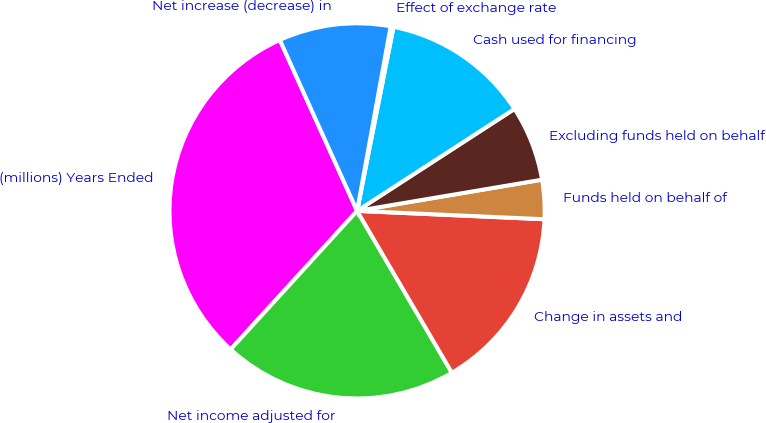Convert chart to OTSL. <chart><loc_0><loc_0><loc_500><loc_500><pie_chart><fcel>(millions) Years Ended<fcel>Net income adjusted for<fcel>Change in assets and<fcel>Funds held on behalf of<fcel>Excluding funds held on behalf<fcel>Cash used for financing<fcel>Effect of exchange rate<fcel>Net increase (decrease) in<nl><fcel>31.47%<fcel>20.21%<fcel>15.86%<fcel>3.37%<fcel>6.49%<fcel>12.74%<fcel>0.25%<fcel>9.62%<nl></chart> 